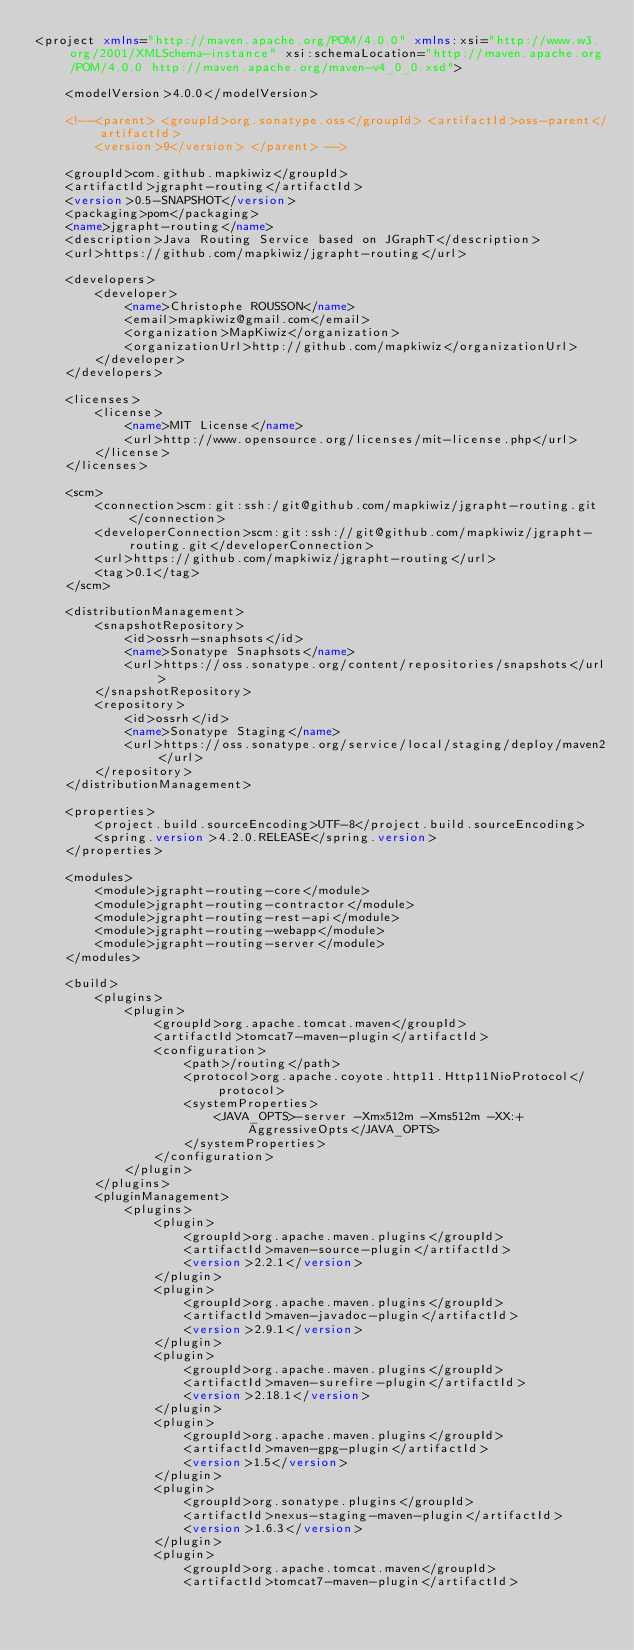<code> <loc_0><loc_0><loc_500><loc_500><_XML_><project xmlns="http://maven.apache.org/POM/4.0.0" xmlns:xsi="http://www.w3.org/2001/XMLSchema-instance" xsi:schemaLocation="http://maven.apache.org/POM/4.0.0 http://maven.apache.org/maven-v4_0_0.xsd">

	<modelVersion>4.0.0</modelVersion>

	<!--<parent> <groupId>org.sonatype.oss</groupId> <artifactId>oss-parent</artifactId> 
		<version>9</version> </parent> -->

	<groupId>com.github.mapkiwiz</groupId>
	<artifactId>jgrapht-routing</artifactId>
	<version>0.5-SNAPSHOT</version>
	<packaging>pom</packaging>
	<name>jgrapht-routing</name>
	<description>Java Routing Service based on JGraphT</description>
	<url>https://github.com/mapkiwiz/jgrapht-routing</url>

	<developers>
		<developer>
			<name>Christophe ROUSSON</name>
			<email>mapkiwiz@gmail.com</email>
			<organization>MapKiwiz</organization>
			<organizationUrl>http://github.com/mapkiwiz</organizationUrl>
		</developer>
	</developers>

	<licenses>
		<license>
			<name>MIT License</name>
			<url>http://www.opensource.org/licenses/mit-license.php</url>
		</license>
	</licenses>

	<scm>
		<connection>scm:git:ssh:/git@github.com/mapkiwiz/jgrapht-routing.git</connection>
		<developerConnection>scm:git:ssh://git@github.com/mapkiwiz/jgrapht-routing.git</developerConnection>
		<url>https://github.com/mapkiwiz/jgrapht-routing</url>
		<tag>0.1</tag>
	</scm>

	<distributionManagement>
		<snapshotRepository>
			<id>ossrh-snaphsots</id>
			<name>Sonatype Snaphsots</name>
			<url>https://oss.sonatype.org/content/repositories/snapshots</url>
		</snapshotRepository>
		<repository>
			<id>ossrh</id>
			<name>Sonatype Staging</name>
			<url>https://oss.sonatype.org/service/local/staging/deploy/maven2</url>
		</repository>
	</distributionManagement>

	<properties>
		<project.build.sourceEncoding>UTF-8</project.build.sourceEncoding>
		<spring.version>4.2.0.RELEASE</spring.version>
	</properties>

	<modules>
		<module>jgrapht-routing-core</module>
		<module>jgrapht-routing-contractor</module>
		<module>jgrapht-routing-rest-api</module>
		<module>jgrapht-routing-webapp</module>
		<module>jgrapht-routing-server</module>
	</modules>

	<build>
		<plugins>
			<plugin>
				<groupId>org.apache.tomcat.maven</groupId>
				<artifactId>tomcat7-maven-plugin</artifactId>
				<configuration>
					<path>/routing</path>
					<protocol>org.apache.coyote.http11.Http11NioProtocol</protocol>
					<systemProperties>
						<JAVA_OPTS>-server -Xmx512m -Xms512m -XX:+AggressiveOpts</JAVA_OPTS>
					</systemProperties>
				</configuration>
			</plugin>
		</plugins>
		<pluginManagement>
			<plugins>
				<plugin>
					<groupId>org.apache.maven.plugins</groupId>
					<artifactId>maven-source-plugin</artifactId>
					<version>2.2.1</version>
				</plugin>
				<plugin>
					<groupId>org.apache.maven.plugins</groupId>
					<artifactId>maven-javadoc-plugin</artifactId>
					<version>2.9.1</version>
				</plugin>
				<plugin>
					<groupId>org.apache.maven.plugins</groupId>
					<artifactId>maven-surefire-plugin</artifactId>
					<version>2.18.1</version>
				</plugin>
				<plugin>
					<groupId>org.apache.maven.plugins</groupId>
					<artifactId>maven-gpg-plugin</artifactId>
					<version>1.5</version>
				</plugin>
				<plugin>
					<groupId>org.sonatype.plugins</groupId>
					<artifactId>nexus-staging-maven-plugin</artifactId>
					<version>1.6.3</version>
				</plugin>
				<plugin>
					<groupId>org.apache.tomcat.maven</groupId>
					<artifactId>tomcat7-maven-plugin</artifactId></code> 